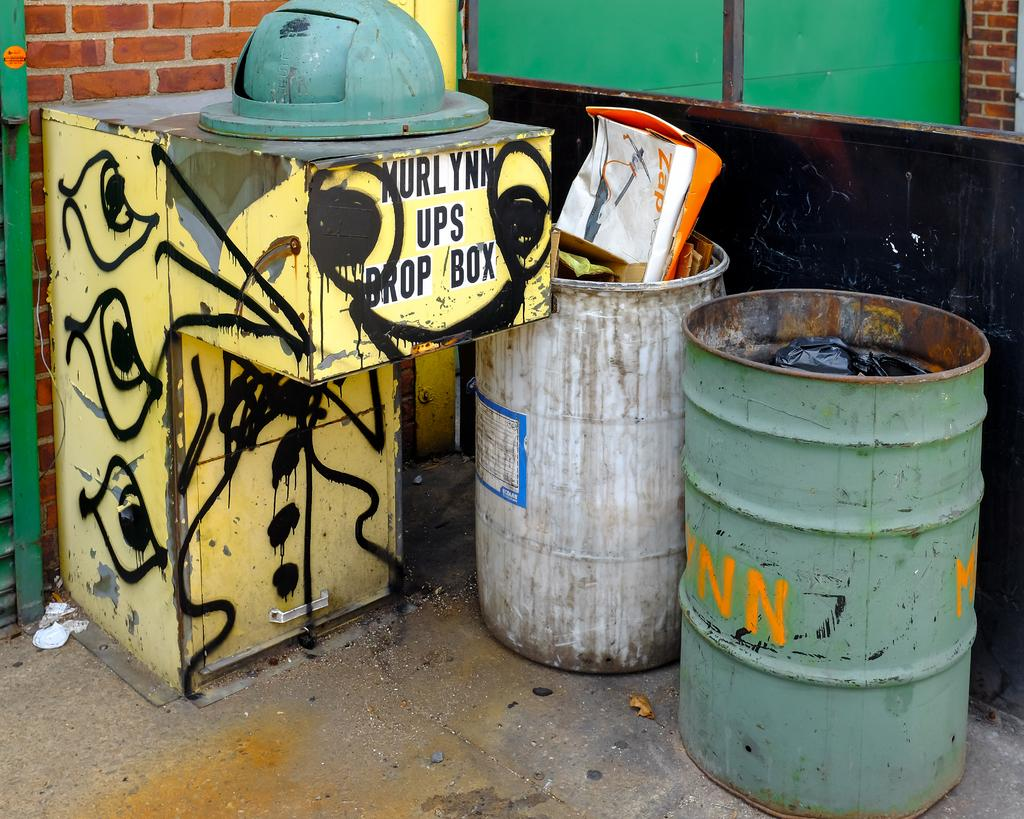<image>
Summarize the visual content of the image. A Murlynn UPS Drop Box is heavily graffitied and sits next to two barells, one with the letters NN on it. 